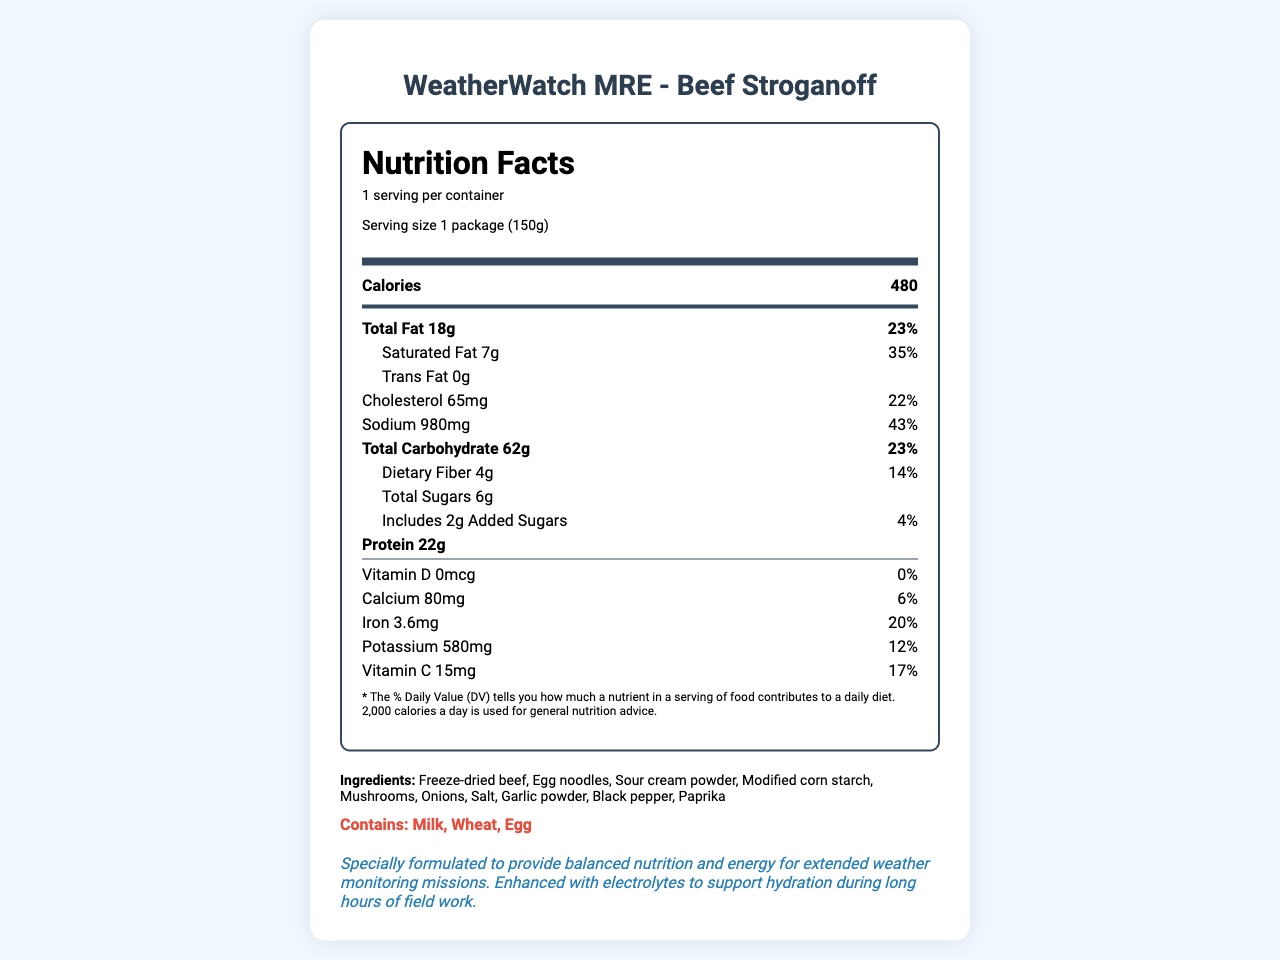what is the serving size of WeatherWatch MRE - Beef Stroganoff? The serving size is indicated in the "serving-info" section beneath the Nutrition Facts header, where it states "Serving size 1 package (150g)."
Answer: 1 package (150g) how much protein does one serving contain? The protein content is listed under bold nutrition items where it states "Protein 22g."
Answer: 22g what percentage of daily sodium value does this product provide? The sodium content is displayed along with its daily value percentage, indicating "Sodium 980mg, 43%."
Answer: 43% name three ingredients found in this product. The ingredients are listed in the "ingredients" section, which states multiple items, including "Freeze-dried beef, egg noodles, sour cream powder."
Answer: Freeze-dried beef, egg noodles, sour cream powder what is the recommended preparation instruction? The preparation instructions are at the end of the document, stating the steps to prepare the meal.
Answer: Add 1 cup (240ml) of boiling water. Stir and let stand for 10 minutes. Stir again before consuming. which of the following is an allergen contained in the product? A. Soy B. Milk C. Peanuts The allergens section clearly lists "Milk, Wheat, Egg" as the allergens.
Answer: B what is the amount of added sugars in grams? The added sugars are mentioned in the sub-item under total sugars, stating "Includes 2g Added Sugars."
Answer: 2g does the document mention the product is GMO-free? Under certifications, the product is labeled "Non-GMO".
Answer: Yes describe the overall purpose of this document in one sentence. The entire document focuses on giving comprehensive details related to the product's nutritional information, ingredients, and usage.
Answer: This document provides detailed nutrition facts, ingredients, allergens, and preparation instructions for the WeatherWatch MRE - Beef Stroganoff, designed for extended weather monitoring missions. what is the shelf life of the product? The shelf life is mentioned in the final part of the information section, stating "5 years when stored in a cool, dry place."
Answer: 5 years what certification is not included in the document? A. USDA inspected B. Organic C. Non-GMO D. Gluten-Free The listed certifications include "USDA inspected" and "Non-GMO," but "Gluten-Free" is not mentioned.
Answer: D how much calcium is in one serving? The calcium amount is displayed under the nutrition item section, stating "Calcium 80mg."
Answer: 80mg can the amount of vitamin D be determined from the document? The vitamin D content is specifically mentioned as "0mcg."
Answer: Yes is there information about the product's environmental impact? This information is provided under the sustainability info section at the end of the document.
Answer: Yes, the packaging is made from 30% post-consumer recycled materials. how many servings are there per container? The number of servings is mentioned as "1 serving per container" under the serving info section.
Answer: 1 are Electrolytes mentioned in the main nutrition facts table? Electrolytes are mentioned in the mission notes but do not appear in the main nutrition facts table.
Answer: No 